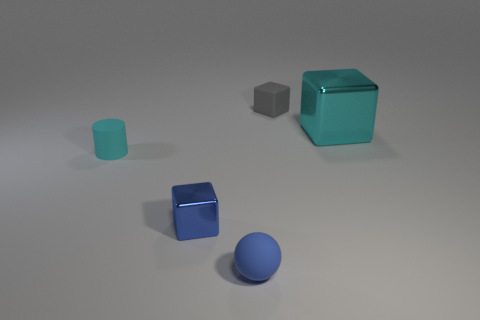Add 3 large green balls. How many objects exist? 8 Subtract all cylinders. How many objects are left? 4 Subtract 0 brown cylinders. How many objects are left? 5 Subtract all big blue rubber cubes. Subtract all balls. How many objects are left? 4 Add 4 blue metal objects. How many blue metal objects are left? 5 Add 1 small cylinders. How many small cylinders exist? 2 